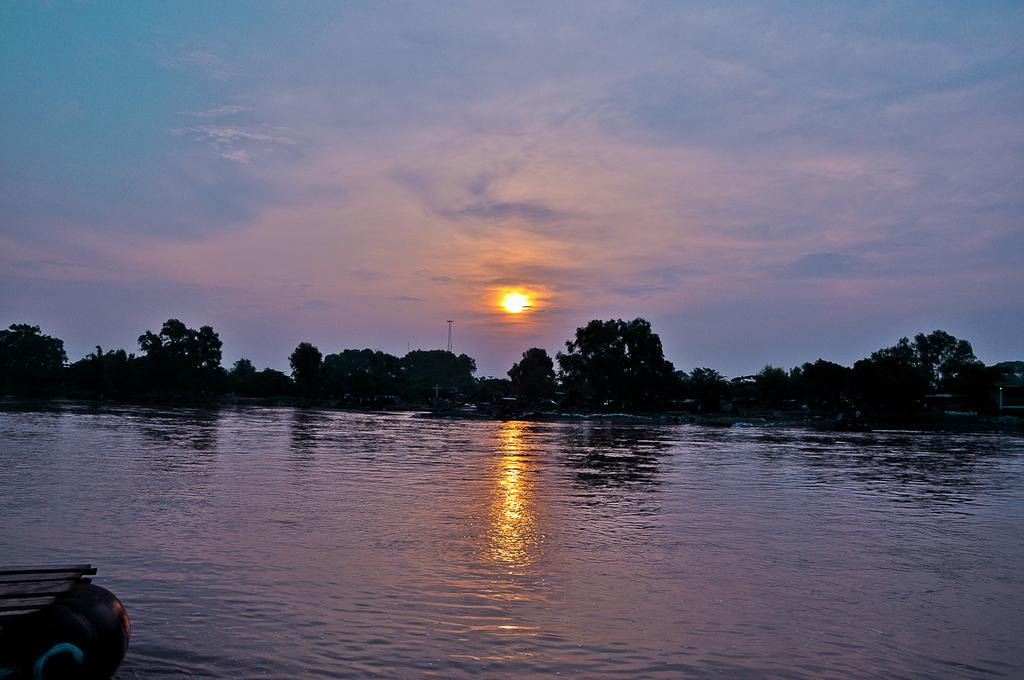What type of vegetation can be seen in the image? There are trees in the image. What natural element is visible in the image? There is water visible in the image. How would you describe the sky in the image? The sky appears cloudy in the image. Despite the cloudy sky, what can still be seen in the image? Sunlight is visible in the image. Where is the playground located in the image? There is no playground present in the image. What type of hope can be seen in the image? There is no reference to hope in the image, as it features trees, water, a cloudy sky, and sunlight. 